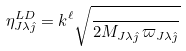Convert formula to latex. <formula><loc_0><loc_0><loc_500><loc_500>\eta _ { J \lambda \hat { \jmath } } ^ { L D } = k ^ { \ell } \sqrt { \frac { } { 2 M _ { J \lambda \hat { \jmath } } \, \varpi _ { J \lambda \hat { \jmath } } } }</formula> 